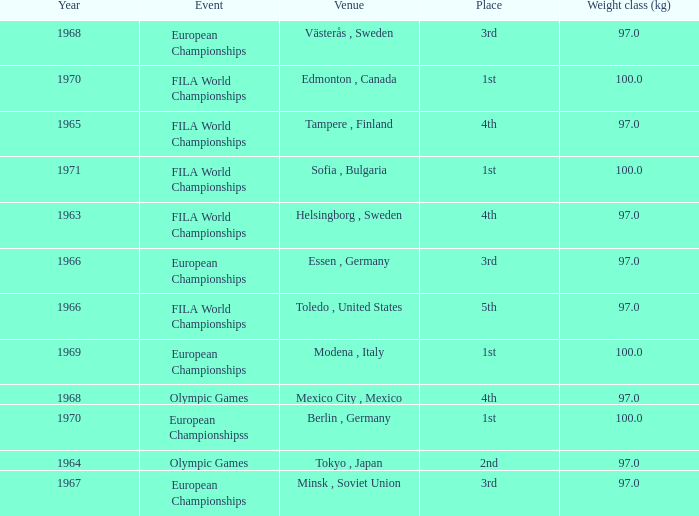What is the lowest weight class (kg) that has sofia, bulgaria as the venue? 100.0. 